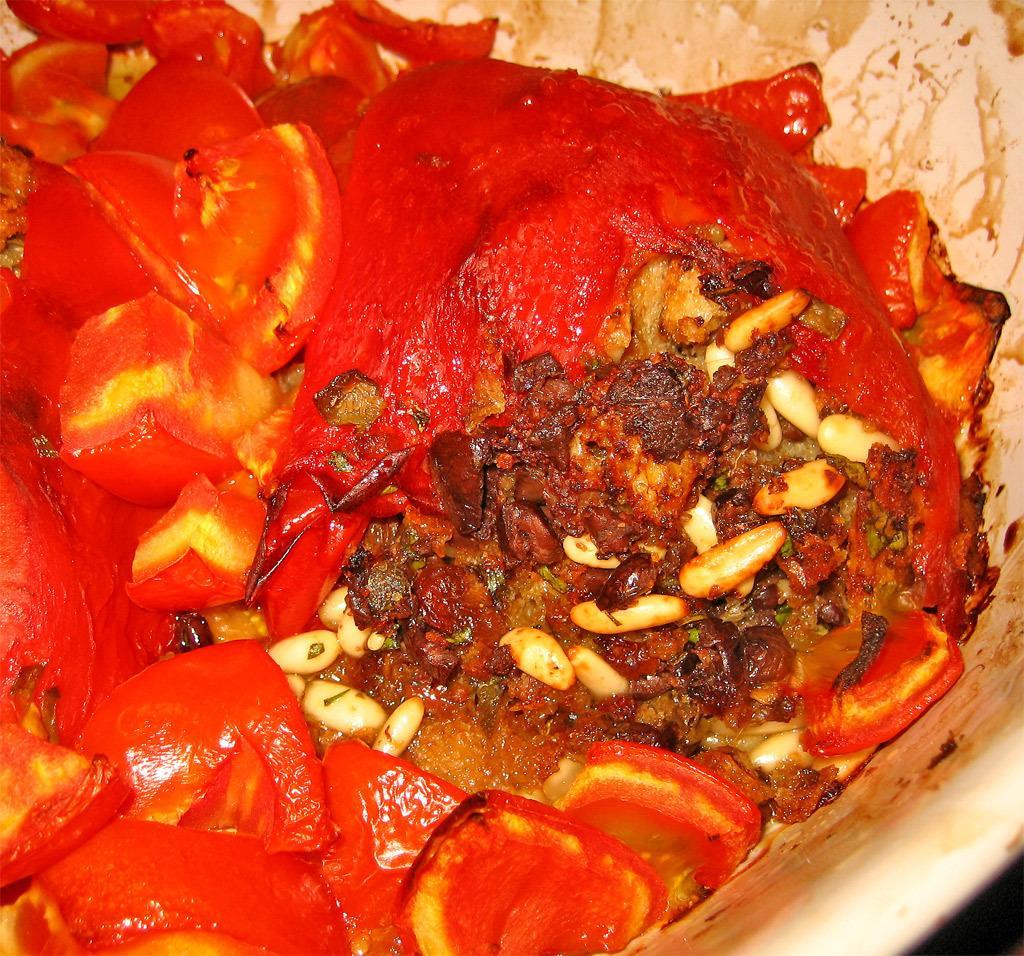How would you summarize this image in a sentence or two? In this image we can see a food item in a white color bowl. 